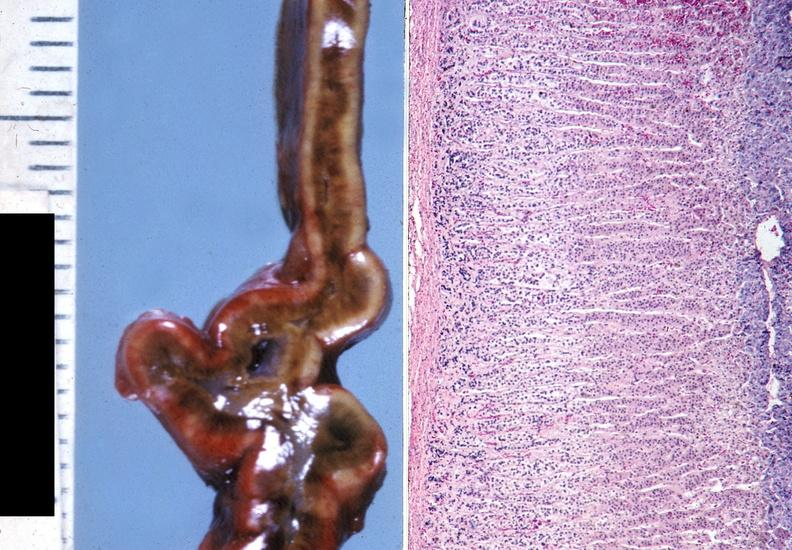what is present?
Answer the question using a single word or phrase. Endocrine 